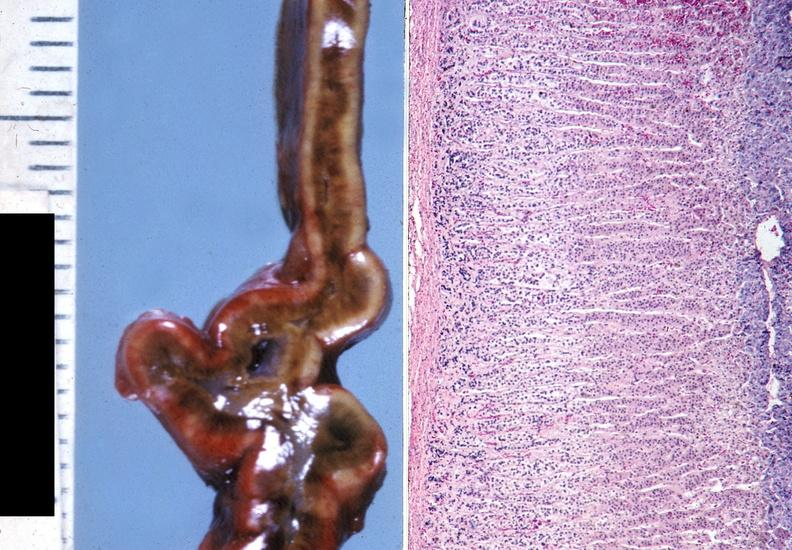what is present?
Answer the question using a single word or phrase. Endocrine 